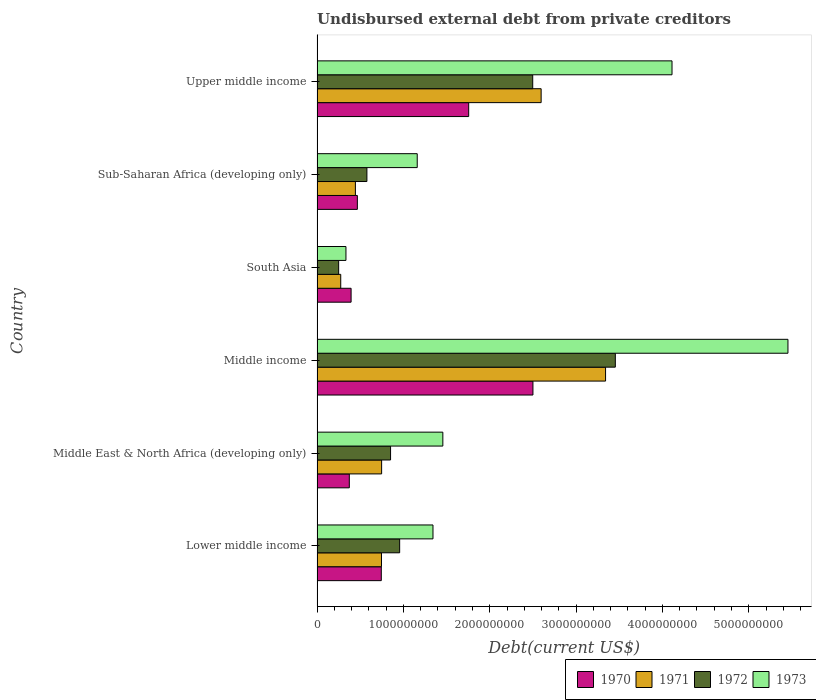How many groups of bars are there?
Provide a succinct answer. 6. Are the number of bars on each tick of the Y-axis equal?
Your answer should be compact. Yes. How many bars are there on the 2nd tick from the top?
Give a very brief answer. 4. What is the label of the 5th group of bars from the top?
Keep it short and to the point. Middle East & North Africa (developing only). In how many cases, is the number of bars for a given country not equal to the number of legend labels?
Offer a very short reply. 0. What is the total debt in 1972 in Sub-Saharan Africa (developing only)?
Make the answer very short. 5.77e+08. Across all countries, what is the maximum total debt in 1972?
Your answer should be compact. 3.45e+09. Across all countries, what is the minimum total debt in 1972?
Give a very brief answer. 2.50e+08. What is the total total debt in 1970 in the graph?
Your response must be concise. 6.24e+09. What is the difference between the total debt in 1972 in Lower middle income and that in Upper middle income?
Your response must be concise. -1.54e+09. What is the difference between the total debt in 1972 in Middle income and the total debt in 1973 in Upper middle income?
Your answer should be compact. -6.57e+08. What is the average total debt in 1971 per country?
Give a very brief answer. 1.36e+09. What is the difference between the total debt in 1971 and total debt in 1970 in Middle East & North Africa (developing only)?
Provide a short and direct response. 3.74e+08. What is the ratio of the total debt in 1971 in South Asia to that in Sub-Saharan Africa (developing only)?
Give a very brief answer. 0.62. Is the total debt in 1971 in Middle East & North Africa (developing only) less than that in Upper middle income?
Make the answer very short. Yes. Is the difference between the total debt in 1971 in Middle East & North Africa (developing only) and Sub-Saharan Africa (developing only) greater than the difference between the total debt in 1970 in Middle East & North Africa (developing only) and Sub-Saharan Africa (developing only)?
Your answer should be compact. Yes. What is the difference between the highest and the second highest total debt in 1971?
Offer a terse response. 7.46e+08. What is the difference between the highest and the lowest total debt in 1970?
Offer a terse response. 2.13e+09. In how many countries, is the total debt in 1971 greater than the average total debt in 1971 taken over all countries?
Keep it short and to the point. 2. Is the sum of the total debt in 1972 in Lower middle income and Middle income greater than the maximum total debt in 1971 across all countries?
Provide a succinct answer. Yes. Is it the case that in every country, the sum of the total debt in 1972 and total debt in 1970 is greater than the sum of total debt in 1971 and total debt in 1973?
Your answer should be compact. No. What does the 3rd bar from the top in Middle East & North Africa (developing only) represents?
Your response must be concise. 1971. Is it the case that in every country, the sum of the total debt in 1970 and total debt in 1972 is greater than the total debt in 1971?
Your answer should be compact. Yes. How many bars are there?
Your answer should be compact. 24. How many countries are there in the graph?
Provide a succinct answer. 6. What is the difference between two consecutive major ticks on the X-axis?
Ensure brevity in your answer.  1.00e+09. Does the graph contain any zero values?
Offer a very short reply. No. Does the graph contain grids?
Provide a succinct answer. No. Where does the legend appear in the graph?
Your answer should be compact. Bottom right. How are the legend labels stacked?
Your response must be concise. Horizontal. What is the title of the graph?
Your answer should be very brief. Undisbursed external debt from private creditors. Does "1998" appear as one of the legend labels in the graph?
Keep it short and to the point. No. What is the label or title of the X-axis?
Provide a succinct answer. Debt(current US$). What is the Debt(current US$) of 1970 in Lower middle income?
Provide a succinct answer. 7.44e+08. What is the Debt(current US$) of 1971 in Lower middle income?
Your response must be concise. 7.46e+08. What is the Debt(current US$) in 1972 in Lower middle income?
Offer a terse response. 9.57e+08. What is the Debt(current US$) of 1973 in Lower middle income?
Offer a very short reply. 1.34e+09. What is the Debt(current US$) of 1970 in Middle East & North Africa (developing only)?
Your answer should be very brief. 3.74e+08. What is the Debt(current US$) of 1971 in Middle East & North Africa (developing only)?
Offer a terse response. 7.48e+08. What is the Debt(current US$) in 1972 in Middle East & North Africa (developing only)?
Provide a short and direct response. 8.51e+08. What is the Debt(current US$) of 1973 in Middle East & North Africa (developing only)?
Provide a short and direct response. 1.46e+09. What is the Debt(current US$) of 1970 in Middle income?
Offer a terse response. 2.50e+09. What is the Debt(current US$) in 1971 in Middle income?
Provide a short and direct response. 3.34e+09. What is the Debt(current US$) of 1972 in Middle income?
Give a very brief answer. 3.45e+09. What is the Debt(current US$) in 1973 in Middle income?
Make the answer very short. 5.45e+09. What is the Debt(current US$) in 1970 in South Asia?
Your answer should be compact. 3.94e+08. What is the Debt(current US$) in 1971 in South Asia?
Make the answer very short. 2.74e+08. What is the Debt(current US$) of 1972 in South Asia?
Provide a succinct answer. 2.50e+08. What is the Debt(current US$) of 1973 in South Asia?
Provide a short and direct response. 3.35e+08. What is the Debt(current US$) of 1970 in Sub-Saharan Africa (developing only)?
Your answer should be compact. 4.67e+08. What is the Debt(current US$) in 1971 in Sub-Saharan Africa (developing only)?
Give a very brief answer. 4.44e+08. What is the Debt(current US$) in 1972 in Sub-Saharan Africa (developing only)?
Keep it short and to the point. 5.77e+08. What is the Debt(current US$) of 1973 in Sub-Saharan Africa (developing only)?
Your answer should be compact. 1.16e+09. What is the Debt(current US$) in 1970 in Upper middle income?
Provide a short and direct response. 1.76e+09. What is the Debt(current US$) in 1971 in Upper middle income?
Your answer should be very brief. 2.60e+09. What is the Debt(current US$) of 1972 in Upper middle income?
Your response must be concise. 2.50e+09. What is the Debt(current US$) of 1973 in Upper middle income?
Offer a very short reply. 4.11e+09. Across all countries, what is the maximum Debt(current US$) in 1970?
Offer a terse response. 2.50e+09. Across all countries, what is the maximum Debt(current US$) of 1971?
Your response must be concise. 3.34e+09. Across all countries, what is the maximum Debt(current US$) in 1972?
Offer a terse response. 3.45e+09. Across all countries, what is the maximum Debt(current US$) in 1973?
Provide a short and direct response. 5.45e+09. Across all countries, what is the minimum Debt(current US$) of 1970?
Keep it short and to the point. 3.74e+08. Across all countries, what is the minimum Debt(current US$) in 1971?
Offer a terse response. 2.74e+08. Across all countries, what is the minimum Debt(current US$) in 1972?
Provide a short and direct response. 2.50e+08. Across all countries, what is the minimum Debt(current US$) in 1973?
Give a very brief answer. 3.35e+08. What is the total Debt(current US$) in 1970 in the graph?
Offer a terse response. 6.24e+09. What is the total Debt(current US$) of 1971 in the graph?
Your answer should be very brief. 8.15e+09. What is the total Debt(current US$) of 1972 in the graph?
Offer a terse response. 8.59e+09. What is the total Debt(current US$) of 1973 in the graph?
Give a very brief answer. 1.39e+1. What is the difference between the Debt(current US$) of 1970 in Lower middle income and that in Middle East & North Africa (developing only)?
Make the answer very short. 3.71e+08. What is the difference between the Debt(current US$) of 1971 in Lower middle income and that in Middle East & North Africa (developing only)?
Your answer should be very brief. -1.62e+06. What is the difference between the Debt(current US$) of 1972 in Lower middle income and that in Middle East & North Africa (developing only)?
Your answer should be compact. 1.05e+08. What is the difference between the Debt(current US$) of 1973 in Lower middle income and that in Middle East & North Africa (developing only)?
Provide a succinct answer. -1.14e+08. What is the difference between the Debt(current US$) of 1970 in Lower middle income and that in Middle income?
Ensure brevity in your answer.  -1.76e+09. What is the difference between the Debt(current US$) in 1971 in Lower middle income and that in Middle income?
Offer a terse response. -2.60e+09. What is the difference between the Debt(current US$) in 1972 in Lower middle income and that in Middle income?
Ensure brevity in your answer.  -2.50e+09. What is the difference between the Debt(current US$) of 1973 in Lower middle income and that in Middle income?
Your answer should be very brief. -4.11e+09. What is the difference between the Debt(current US$) of 1970 in Lower middle income and that in South Asia?
Keep it short and to the point. 3.50e+08. What is the difference between the Debt(current US$) in 1971 in Lower middle income and that in South Asia?
Offer a terse response. 4.72e+08. What is the difference between the Debt(current US$) of 1972 in Lower middle income and that in South Asia?
Give a very brief answer. 7.07e+08. What is the difference between the Debt(current US$) of 1973 in Lower middle income and that in South Asia?
Keep it short and to the point. 1.01e+09. What is the difference between the Debt(current US$) in 1970 in Lower middle income and that in Sub-Saharan Africa (developing only)?
Your answer should be very brief. 2.77e+08. What is the difference between the Debt(current US$) in 1971 in Lower middle income and that in Sub-Saharan Africa (developing only)?
Keep it short and to the point. 3.02e+08. What is the difference between the Debt(current US$) in 1972 in Lower middle income and that in Sub-Saharan Africa (developing only)?
Offer a very short reply. 3.79e+08. What is the difference between the Debt(current US$) of 1973 in Lower middle income and that in Sub-Saharan Africa (developing only)?
Provide a short and direct response. 1.82e+08. What is the difference between the Debt(current US$) in 1970 in Lower middle income and that in Upper middle income?
Give a very brief answer. -1.01e+09. What is the difference between the Debt(current US$) in 1971 in Lower middle income and that in Upper middle income?
Your response must be concise. -1.85e+09. What is the difference between the Debt(current US$) in 1972 in Lower middle income and that in Upper middle income?
Make the answer very short. -1.54e+09. What is the difference between the Debt(current US$) of 1973 in Lower middle income and that in Upper middle income?
Your response must be concise. -2.77e+09. What is the difference between the Debt(current US$) in 1970 in Middle East & North Africa (developing only) and that in Middle income?
Keep it short and to the point. -2.13e+09. What is the difference between the Debt(current US$) in 1971 in Middle East & North Africa (developing only) and that in Middle income?
Offer a very short reply. -2.59e+09. What is the difference between the Debt(current US$) in 1972 in Middle East & North Africa (developing only) and that in Middle income?
Make the answer very short. -2.60e+09. What is the difference between the Debt(current US$) in 1973 in Middle East & North Africa (developing only) and that in Middle income?
Your answer should be compact. -4.00e+09. What is the difference between the Debt(current US$) of 1970 in Middle East & North Africa (developing only) and that in South Asia?
Provide a short and direct response. -2.07e+07. What is the difference between the Debt(current US$) of 1971 in Middle East & North Africa (developing only) and that in South Asia?
Provide a short and direct response. 4.74e+08. What is the difference between the Debt(current US$) of 1972 in Middle East & North Africa (developing only) and that in South Asia?
Keep it short and to the point. 6.01e+08. What is the difference between the Debt(current US$) in 1973 in Middle East & North Africa (developing only) and that in South Asia?
Provide a succinct answer. 1.12e+09. What is the difference between the Debt(current US$) of 1970 in Middle East & North Africa (developing only) and that in Sub-Saharan Africa (developing only)?
Provide a succinct answer. -9.32e+07. What is the difference between the Debt(current US$) of 1971 in Middle East & North Africa (developing only) and that in Sub-Saharan Africa (developing only)?
Give a very brief answer. 3.04e+08. What is the difference between the Debt(current US$) in 1972 in Middle East & North Africa (developing only) and that in Sub-Saharan Africa (developing only)?
Provide a short and direct response. 2.74e+08. What is the difference between the Debt(current US$) of 1973 in Middle East & North Africa (developing only) and that in Sub-Saharan Africa (developing only)?
Provide a short and direct response. 2.97e+08. What is the difference between the Debt(current US$) in 1970 in Middle East & North Africa (developing only) and that in Upper middle income?
Give a very brief answer. -1.38e+09. What is the difference between the Debt(current US$) of 1971 in Middle East & North Africa (developing only) and that in Upper middle income?
Your answer should be very brief. -1.85e+09. What is the difference between the Debt(current US$) in 1972 in Middle East & North Africa (developing only) and that in Upper middle income?
Your answer should be compact. -1.65e+09. What is the difference between the Debt(current US$) of 1973 in Middle East & North Africa (developing only) and that in Upper middle income?
Keep it short and to the point. -2.65e+09. What is the difference between the Debt(current US$) in 1970 in Middle income and that in South Asia?
Offer a very short reply. 2.11e+09. What is the difference between the Debt(current US$) of 1971 in Middle income and that in South Asia?
Keep it short and to the point. 3.07e+09. What is the difference between the Debt(current US$) of 1972 in Middle income and that in South Asia?
Ensure brevity in your answer.  3.20e+09. What is the difference between the Debt(current US$) of 1973 in Middle income and that in South Asia?
Offer a very short reply. 5.12e+09. What is the difference between the Debt(current US$) of 1970 in Middle income and that in Sub-Saharan Africa (developing only)?
Your response must be concise. 2.03e+09. What is the difference between the Debt(current US$) of 1971 in Middle income and that in Sub-Saharan Africa (developing only)?
Ensure brevity in your answer.  2.90e+09. What is the difference between the Debt(current US$) in 1972 in Middle income and that in Sub-Saharan Africa (developing only)?
Ensure brevity in your answer.  2.88e+09. What is the difference between the Debt(current US$) of 1973 in Middle income and that in Sub-Saharan Africa (developing only)?
Your response must be concise. 4.29e+09. What is the difference between the Debt(current US$) of 1970 in Middle income and that in Upper middle income?
Your answer should be very brief. 7.44e+08. What is the difference between the Debt(current US$) of 1971 in Middle income and that in Upper middle income?
Provide a short and direct response. 7.46e+08. What is the difference between the Debt(current US$) in 1972 in Middle income and that in Upper middle income?
Offer a very short reply. 9.57e+08. What is the difference between the Debt(current US$) in 1973 in Middle income and that in Upper middle income?
Offer a very short reply. 1.34e+09. What is the difference between the Debt(current US$) of 1970 in South Asia and that in Sub-Saharan Africa (developing only)?
Your answer should be compact. -7.26e+07. What is the difference between the Debt(current US$) in 1971 in South Asia and that in Sub-Saharan Africa (developing only)?
Offer a terse response. -1.70e+08. What is the difference between the Debt(current US$) in 1972 in South Asia and that in Sub-Saharan Africa (developing only)?
Ensure brevity in your answer.  -3.27e+08. What is the difference between the Debt(current US$) of 1973 in South Asia and that in Sub-Saharan Africa (developing only)?
Provide a succinct answer. -8.26e+08. What is the difference between the Debt(current US$) of 1970 in South Asia and that in Upper middle income?
Provide a short and direct response. -1.36e+09. What is the difference between the Debt(current US$) in 1971 in South Asia and that in Upper middle income?
Provide a succinct answer. -2.32e+09. What is the difference between the Debt(current US$) of 1972 in South Asia and that in Upper middle income?
Offer a terse response. -2.25e+09. What is the difference between the Debt(current US$) of 1973 in South Asia and that in Upper middle income?
Make the answer very short. -3.78e+09. What is the difference between the Debt(current US$) of 1970 in Sub-Saharan Africa (developing only) and that in Upper middle income?
Ensure brevity in your answer.  -1.29e+09. What is the difference between the Debt(current US$) in 1971 in Sub-Saharan Africa (developing only) and that in Upper middle income?
Ensure brevity in your answer.  -2.15e+09. What is the difference between the Debt(current US$) of 1972 in Sub-Saharan Africa (developing only) and that in Upper middle income?
Provide a succinct answer. -1.92e+09. What is the difference between the Debt(current US$) of 1973 in Sub-Saharan Africa (developing only) and that in Upper middle income?
Make the answer very short. -2.95e+09. What is the difference between the Debt(current US$) of 1970 in Lower middle income and the Debt(current US$) of 1971 in Middle East & North Africa (developing only)?
Your answer should be compact. -3.71e+06. What is the difference between the Debt(current US$) in 1970 in Lower middle income and the Debt(current US$) in 1972 in Middle East & North Africa (developing only)?
Make the answer very short. -1.07e+08. What is the difference between the Debt(current US$) of 1970 in Lower middle income and the Debt(current US$) of 1973 in Middle East & North Africa (developing only)?
Keep it short and to the point. -7.13e+08. What is the difference between the Debt(current US$) of 1971 in Lower middle income and the Debt(current US$) of 1972 in Middle East & North Africa (developing only)?
Your response must be concise. -1.05e+08. What is the difference between the Debt(current US$) in 1971 in Lower middle income and the Debt(current US$) in 1973 in Middle East & North Africa (developing only)?
Your answer should be very brief. -7.11e+08. What is the difference between the Debt(current US$) in 1972 in Lower middle income and the Debt(current US$) in 1973 in Middle East & North Africa (developing only)?
Your answer should be compact. -5.00e+08. What is the difference between the Debt(current US$) in 1970 in Lower middle income and the Debt(current US$) in 1971 in Middle income?
Your response must be concise. -2.60e+09. What is the difference between the Debt(current US$) of 1970 in Lower middle income and the Debt(current US$) of 1972 in Middle income?
Your answer should be compact. -2.71e+09. What is the difference between the Debt(current US$) in 1970 in Lower middle income and the Debt(current US$) in 1973 in Middle income?
Your response must be concise. -4.71e+09. What is the difference between the Debt(current US$) of 1971 in Lower middle income and the Debt(current US$) of 1972 in Middle income?
Offer a very short reply. -2.71e+09. What is the difference between the Debt(current US$) in 1971 in Lower middle income and the Debt(current US$) in 1973 in Middle income?
Make the answer very short. -4.71e+09. What is the difference between the Debt(current US$) of 1972 in Lower middle income and the Debt(current US$) of 1973 in Middle income?
Provide a short and direct response. -4.50e+09. What is the difference between the Debt(current US$) in 1970 in Lower middle income and the Debt(current US$) in 1971 in South Asia?
Keep it short and to the point. 4.70e+08. What is the difference between the Debt(current US$) of 1970 in Lower middle income and the Debt(current US$) of 1972 in South Asia?
Your answer should be compact. 4.94e+08. What is the difference between the Debt(current US$) in 1970 in Lower middle income and the Debt(current US$) in 1973 in South Asia?
Offer a very short reply. 4.09e+08. What is the difference between the Debt(current US$) of 1971 in Lower middle income and the Debt(current US$) of 1972 in South Asia?
Provide a succinct answer. 4.96e+08. What is the difference between the Debt(current US$) in 1971 in Lower middle income and the Debt(current US$) in 1973 in South Asia?
Make the answer very short. 4.11e+08. What is the difference between the Debt(current US$) of 1972 in Lower middle income and the Debt(current US$) of 1973 in South Asia?
Make the answer very short. 6.22e+08. What is the difference between the Debt(current US$) of 1970 in Lower middle income and the Debt(current US$) of 1971 in Sub-Saharan Africa (developing only)?
Keep it short and to the point. 3.00e+08. What is the difference between the Debt(current US$) of 1970 in Lower middle income and the Debt(current US$) of 1972 in Sub-Saharan Africa (developing only)?
Provide a short and direct response. 1.67e+08. What is the difference between the Debt(current US$) of 1970 in Lower middle income and the Debt(current US$) of 1973 in Sub-Saharan Africa (developing only)?
Provide a succinct answer. -4.16e+08. What is the difference between the Debt(current US$) of 1971 in Lower middle income and the Debt(current US$) of 1972 in Sub-Saharan Africa (developing only)?
Provide a succinct answer. 1.69e+08. What is the difference between the Debt(current US$) of 1971 in Lower middle income and the Debt(current US$) of 1973 in Sub-Saharan Africa (developing only)?
Offer a very short reply. -4.14e+08. What is the difference between the Debt(current US$) in 1972 in Lower middle income and the Debt(current US$) in 1973 in Sub-Saharan Africa (developing only)?
Provide a short and direct response. -2.04e+08. What is the difference between the Debt(current US$) in 1970 in Lower middle income and the Debt(current US$) in 1971 in Upper middle income?
Your answer should be very brief. -1.85e+09. What is the difference between the Debt(current US$) of 1970 in Lower middle income and the Debt(current US$) of 1972 in Upper middle income?
Provide a succinct answer. -1.75e+09. What is the difference between the Debt(current US$) of 1970 in Lower middle income and the Debt(current US$) of 1973 in Upper middle income?
Your answer should be very brief. -3.37e+09. What is the difference between the Debt(current US$) in 1971 in Lower middle income and the Debt(current US$) in 1972 in Upper middle income?
Your answer should be very brief. -1.75e+09. What is the difference between the Debt(current US$) in 1971 in Lower middle income and the Debt(current US$) in 1973 in Upper middle income?
Offer a terse response. -3.37e+09. What is the difference between the Debt(current US$) in 1972 in Lower middle income and the Debt(current US$) in 1973 in Upper middle income?
Keep it short and to the point. -3.15e+09. What is the difference between the Debt(current US$) in 1970 in Middle East & North Africa (developing only) and the Debt(current US$) in 1971 in Middle income?
Provide a short and direct response. -2.97e+09. What is the difference between the Debt(current US$) of 1970 in Middle East & North Africa (developing only) and the Debt(current US$) of 1972 in Middle income?
Your answer should be compact. -3.08e+09. What is the difference between the Debt(current US$) of 1970 in Middle East & North Africa (developing only) and the Debt(current US$) of 1973 in Middle income?
Offer a terse response. -5.08e+09. What is the difference between the Debt(current US$) of 1971 in Middle East & North Africa (developing only) and the Debt(current US$) of 1972 in Middle income?
Provide a short and direct response. -2.71e+09. What is the difference between the Debt(current US$) in 1971 in Middle East & North Africa (developing only) and the Debt(current US$) in 1973 in Middle income?
Your answer should be very brief. -4.71e+09. What is the difference between the Debt(current US$) of 1972 in Middle East & North Africa (developing only) and the Debt(current US$) of 1973 in Middle income?
Your response must be concise. -4.60e+09. What is the difference between the Debt(current US$) in 1970 in Middle East & North Africa (developing only) and the Debt(current US$) in 1971 in South Asia?
Make the answer very short. 9.92e+07. What is the difference between the Debt(current US$) of 1970 in Middle East & North Africa (developing only) and the Debt(current US$) of 1972 in South Asia?
Your response must be concise. 1.23e+08. What is the difference between the Debt(current US$) in 1970 in Middle East & North Africa (developing only) and the Debt(current US$) in 1973 in South Asia?
Your answer should be compact. 3.88e+07. What is the difference between the Debt(current US$) in 1971 in Middle East & North Africa (developing only) and the Debt(current US$) in 1972 in South Asia?
Give a very brief answer. 4.98e+08. What is the difference between the Debt(current US$) in 1971 in Middle East & North Africa (developing only) and the Debt(current US$) in 1973 in South Asia?
Offer a terse response. 4.13e+08. What is the difference between the Debt(current US$) in 1972 in Middle East & North Africa (developing only) and the Debt(current US$) in 1973 in South Asia?
Keep it short and to the point. 5.17e+08. What is the difference between the Debt(current US$) in 1970 in Middle East & North Africa (developing only) and the Debt(current US$) in 1971 in Sub-Saharan Africa (developing only)?
Your answer should be very brief. -7.04e+07. What is the difference between the Debt(current US$) of 1970 in Middle East & North Africa (developing only) and the Debt(current US$) of 1972 in Sub-Saharan Africa (developing only)?
Ensure brevity in your answer.  -2.04e+08. What is the difference between the Debt(current US$) of 1970 in Middle East & North Africa (developing only) and the Debt(current US$) of 1973 in Sub-Saharan Africa (developing only)?
Offer a very short reply. -7.87e+08. What is the difference between the Debt(current US$) in 1971 in Middle East & North Africa (developing only) and the Debt(current US$) in 1972 in Sub-Saharan Africa (developing only)?
Provide a short and direct response. 1.70e+08. What is the difference between the Debt(current US$) in 1971 in Middle East & North Africa (developing only) and the Debt(current US$) in 1973 in Sub-Saharan Africa (developing only)?
Make the answer very short. -4.12e+08. What is the difference between the Debt(current US$) in 1972 in Middle East & North Africa (developing only) and the Debt(current US$) in 1973 in Sub-Saharan Africa (developing only)?
Offer a terse response. -3.09e+08. What is the difference between the Debt(current US$) in 1970 in Middle East & North Africa (developing only) and the Debt(current US$) in 1971 in Upper middle income?
Give a very brief answer. -2.22e+09. What is the difference between the Debt(current US$) of 1970 in Middle East & North Africa (developing only) and the Debt(current US$) of 1972 in Upper middle income?
Your answer should be compact. -2.12e+09. What is the difference between the Debt(current US$) in 1970 in Middle East & North Africa (developing only) and the Debt(current US$) in 1973 in Upper middle income?
Keep it short and to the point. -3.74e+09. What is the difference between the Debt(current US$) in 1971 in Middle East & North Africa (developing only) and the Debt(current US$) in 1972 in Upper middle income?
Your answer should be compact. -1.75e+09. What is the difference between the Debt(current US$) in 1971 in Middle East & North Africa (developing only) and the Debt(current US$) in 1973 in Upper middle income?
Ensure brevity in your answer.  -3.36e+09. What is the difference between the Debt(current US$) in 1972 in Middle East & North Africa (developing only) and the Debt(current US$) in 1973 in Upper middle income?
Make the answer very short. -3.26e+09. What is the difference between the Debt(current US$) of 1970 in Middle income and the Debt(current US$) of 1971 in South Asia?
Give a very brief answer. 2.23e+09. What is the difference between the Debt(current US$) of 1970 in Middle income and the Debt(current US$) of 1972 in South Asia?
Give a very brief answer. 2.25e+09. What is the difference between the Debt(current US$) in 1970 in Middle income and the Debt(current US$) in 1973 in South Asia?
Give a very brief answer. 2.17e+09. What is the difference between the Debt(current US$) in 1971 in Middle income and the Debt(current US$) in 1972 in South Asia?
Your response must be concise. 3.09e+09. What is the difference between the Debt(current US$) in 1971 in Middle income and the Debt(current US$) in 1973 in South Asia?
Offer a very short reply. 3.01e+09. What is the difference between the Debt(current US$) in 1972 in Middle income and the Debt(current US$) in 1973 in South Asia?
Your answer should be compact. 3.12e+09. What is the difference between the Debt(current US$) in 1970 in Middle income and the Debt(current US$) in 1971 in Sub-Saharan Africa (developing only)?
Your answer should be very brief. 2.06e+09. What is the difference between the Debt(current US$) of 1970 in Middle income and the Debt(current US$) of 1972 in Sub-Saharan Africa (developing only)?
Offer a terse response. 1.92e+09. What is the difference between the Debt(current US$) in 1970 in Middle income and the Debt(current US$) in 1973 in Sub-Saharan Africa (developing only)?
Your answer should be very brief. 1.34e+09. What is the difference between the Debt(current US$) of 1971 in Middle income and the Debt(current US$) of 1972 in Sub-Saharan Africa (developing only)?
Give a very brief answer. 2.76e+09. What is the difference between the Debt(current US$) of 1971 in Middle income and the Debt(current US$) of 1973 in Sub-Saharan Africa (developing only)?
Ensure brevity in your answer.  2.18e+09. What is the difference between the Debt(current US$) in 1972 in Middle income and the Debt(current US$) in 1973 in Sub-Saharan Africa (developing only)?
Your response must be concise. 2.29e+09. What is the difference between the Debt(current US$) of 1970 in Middle income and the Debt(current US$) of 1971 in Upper middle income?
Your response must be concise. -9.50e+07. What is the difference between the Debt(current US$) in 1970 in Middle income and the Debt(current US$) in 1972 in Upper middle income?
Provide a succinct answer. 2.49e+06. What is the difference between the Debt(current US$) of 1970 in Middle income and the Debt(current US$) of 1973 in Upper middle income?
Provide a short and direct response. -1.61e+09. What is the difference between the Debt(current US$) in 1971 in Middle income and the Debt(current US$) in 1972 in Upper middle income?
Provide a short and direct response. 8.44e+08. What is the difference between the Debt(current US$) in 1971 in Middle income and the Debt(current US$) in 1973 in Upper middle income?
Make the answer very short. -7.70e+08. What is the difference between the Debt(current US$) of 1972 in Middle income and the Debt(current US$) of 1973 in Upper middle income?
Your response must be concise. -6.57e+08. What is the difference between the Debt(current US$) in 1970 in South Asia and the Debt(current US$) in 1971 in Sub-Saharan Africa (developing only)?
Your response must be concise. -4.98e+07. What is the difference between the Debt(current US$) of 1970 in South Asia and the Debt(current US$) of 1972 in Sub-Saharan Africa (developing only)?
Keep it short and to the point. -1.83e+08. What is the difference between the Debt(current US$) in 1970 in South Asia and the Debt(current US$) in 1973 in Sub-Saharan Africa (developing only)?
Ensure brevity in your answer.  -7.66e+08. What is the difference between the Debt(current US$) in 1971 in South Asia and the Debt(current US$) in 1972 in Sub-Saharan Africa (developing only)?
Provide a short and direct response. -3.03e+08. What is the difference between the Debt(current US$) in 1971 in South Asia and the Debt(current US$) in 1973 in Sub-Saharan Africa (developing only)?
Your answer should be very brief. -8.86e+08. What is the difference between the Debt(current US$) in 1972 in South Asia and the Debt(current US$) in 1973 in Sub-Saharan Africa (developing only)?
Your answer should be very brief. -9.10e+08. What is the difference between the Debt(current US$) of 1970 in South Asia and the Debt(current US$) of 1971 in Upper middle income?
Keep it short and to the point. -2.20e+09. What is the difference between the Debt(current US$) of 1970 in South Asia and the Debt(current US$) of 1972 in Upper middle income?
Your answer should be compact. -2.10e+09. What is the difference between the Debt(current US$) in 1970 in South Asia and the Debt(current US$) in 1973 in Upper middle income?
Provide a succinct answer. -3.72e+09. What is the difference between the Debt(current US$) of 1971 in South Asia and the Debt(current US$) of 1972 in Upper middle income?
Your answer should be compact. -2.22e+09. What is the difference between the Debt(current US$) in 1971 in South Asia and the Debt(current US$) in 1973 in Upper middle income?
Your response must be concise. -3.84e+09. What is the difference between the Debt(current US$) in 1972 in South Asia and the Debt(current US$) in 1973 in Upper middle income?
Provide a short and direct response. -3.86e+09. What is the difference between the Debt(current US$) in 1970 in Sub-Saharan Africa (developing only) and the Debt(current US$) in 1971 in Upper middle income?
Offer a terse response. -2.13e+09. What is the difference between the Debt(current US$) in 1970 in Sub-Saharan Africa (developing only) and the Debt(current US$) in 1972 in Upper middle income?
Ensure brevity in your answer.  -2.03e+09. What is the difference between the Debt(current US$) of 1970 in Sub-Saharan Africa (developing only) and the Debt(current US$) of 1973 in Upper middle income?
Your response must be concise. -3.64e+09. What is the difference between the Debt(current US$) of 1971 in Sub-Saharan Africa (developing only) and the Debt(current US$) of 1972 in Upper middle income?
Ensure brevity in your answer.  -2.05e+09. What is the difference between the Debt(current US$) of 1971 in Sub-Saharan Africa (developing only) and the Debt(current US$) of 1973 in Upper middle income?
Provide a short and direct response. -3.67e+09. What is the difference between the Debt(current US$) of 1972 in Sub-Saharan Africa (developing only) and the Debt(current US$) of 1973 in Upper middle income?
Your answer should be very brief. -3.53e+09. What is the average Debt(current US$) in 1970 per country?
Offer a very short reply. 1.04e+09. What is the average Debt(current US$) of 1971 per country?
Your answer should be compact. 1.36e+09. What is the average Debt(current US$) of 1972 per country?
Your response must be concise. 1.43e+09. What is the average Debt(current US$) in 1973 per country?
Offer a very short reply. 2.31e+09. What is the difference between the Debt(current US$) of 1970 and Debt(current US$) of 1971 in Lower middle income?
Provide a short and direct response. -2.10e+06. What is the difference between the Debt(current US$) in 1970 and Debt(current US$) in 1972 in Lower middle income?
Ensure brevity in your answer.  -2.13e+08. What is the difference between the Debt(current US$) of 1970 and Debt(current US$) of 1973 in Lower middle income?
Provide a succinct answer. -5.99e+08. What is the difference between the Debt(current US$) of 1971 and Debt(current US$) of 1972 in Lower middle income?
Your answer should be very brief. -2.11e+08. What is the difference between the Debt(current US$) of 1971 and Debt(current US$) of 1973 in Lower middle income?
Offer a terse response. -5.97e+08. What is the difference between the Debt(current US$) in 1972 and Debt(current US$) in 1973 in Lower middle income?
Your answer should be compact. -3.86e+08. What is the difference between the Debt(current US$) in 1970 and Debt(current US$) in 1971 in Middle East & North Africa (developing only)?
Ensure brevity in your answer.  -3.74e+08. What is the difference between the Debt(current US$) in 1970 and Debt(current US$) in 1972 in Middle East & North Africa (developing only)?
Offer a terse response. -4.78e+08. What is the difference between the Debt(current US$) of 1970 and Debt(current US$) of 1973 in Middle East & North Africa (developing only)?
Your answer should be very brief. -1.08e+09. What is the difference between the Debt(current US$) of 1971 and Debt(current US$) of 1972 in Middle East & North Africa (developing only)?
Make the answer very short. -1.04e+08. What is the difference between the Debt(current US$) of 1971 and Debt(current US$) of 1973 in Middle East & North Africa (developing only)?
Your answer should be compact. -7.09e+08. What is the difference between the Debt(current US$) of 1972 and Debt(current US$) of 1973 in Middle East & North Africa (developing only)?
Your answer should be very brief. -6.06e+08. What is the difference between the Debt(current US$) of 1970 and Debt(current US$) of 1971 in Middle income?
Your response must be concise. -8.41e+08. What is the difference between the Debt(current US$) of 1970 and Debt(current US$) of 1972 in Middle income?
Offer a very short reply. -9.54e+08. What is the difference between the Debt(current US$) of 1970 and Debt(current US$) of 1973 in Middle income?
Make the answer very short. -2.95e+09. What is the difference between the Debt(current US$) in 1971 and Debt(current US$) in 1972 in Middle income?
Offer a very short reply. -1.13e+08. What is the difference between the Debt(current US$) of 1971 and Debt(current US$) of 1973 in Middle income?
Make the answer very short. -2.11e+09. What is the difference between the Debt(current US$) in 1972 and Debt(current US$) in 1973 in Middle income?
Ensure brevity in your answer.  -2.00e+09. What is the difference between the Debt(current US$) of 1970 and Debt(current US$) of 1971 in South Asia?
Your answer should be very brief. 1.20e+08. What is the difference between the Debt(current US$) of 1970 and Debt(current US$) of 1972 in South Asia?
Keep it short and to the point. 1.44e+08. What is the difference between the Debt(current US$) in 1970 and Debt(current US$) in 1973 in South Asia?
Your answer should be compact. 5.95e+07. What is the difference between the Debt(current US$) of 1971 and Debt(current US$) of 1972 in South Asia?
Your answer should be compact. 2.41e+07. What is the difference between the Debt(current US$) of 1971 and Debt(current US$) of 1973 in South Asia?
Your answer should be very brief. -6.04e+07. What is the difference between the Debt(current US$) of 1972 and Debt(current US$) of 1973 in South Asia?
Keep it short and to the point. -8.45e+07. What is the difference between the Debt(current US$) in 1970 and Debt(current US$) in 1971 in Sub-Saharan Africa (developing only)?
Ensure brevity in your answer.  2.28e+07. What is the difference between the Debt(current US$) in 1970 and Debt(current US$) in 1972 in Sub-Saharan Africa (developing only)?
Offer a terse response. -1.11e+08. What is the difference between the Debt(current US$) of 1970 and Debt(current US$) of 1973 in Sub-Saharan Africa (developing only)?
Your answer should be compact. -6.94e+08. What is the difference between the Debt(current US$) of 1971 and Debt(current US$) of 1972 in Sub-Saharan Africa (developing only)?
Your answer should be compact. -1.33e+08. What is the difference between the Debt(current US$) in 1971 and Debt(current US$) in 1973 in Sub-Saharan Africa (developing only)?
Give a very brief answer. -7.16e+08. What is the difference between the Debt(current US$) of 1972 and Debt(current US$) of 1973 in Sub-Saharan Africa (developing only)?
Provide a short and direct response. -5.83e+08. What is the difference between the Debt(current US$) in 1970 and Debt(current US$) in 1971 in Upper middle income?
Your answer should be very brief. -8.39e+08. What is the difference between the Debt(current US$) of 1970 and Debt(current US$) of 1972 in Upper middle income?
Offer a terse response. -7.42e+08. What is the difference between the Debt(current US$) in 1970 and Debt(current US$) in 1973 in Upper middle income?
Your response must be concise. -2.36e+09. What is the difference between the Debt(current US$) of 1971 and Debt(current US$) of 1972 in Upper middle income?
Keep it short and to the point. 9.75e+07. What is the difference between the Debt(current US$) in 1971 and Debt(current US$) in 1973 in Upper middle income?
Your answer should be very brief. -1.52e+09. What is the difference between the Debt(current US$) of 1972 and Debt(current US$) of 1973 in Upper middle income?
Provide a succinct answer. -1.61e+09. What is the ratio of the Debt(current US$) of 1970 in Lower middle income to that in Middle East & North Africa (developing only)?
Your answer should be very brief. 1.99. What is the ratio of the Debt(current US$) in 1972 in Lower middle income to that in Middle East & North Africa (developing only)?
Your response must be concise. 1.12. What is the ratio of the Debt(current US$) of 1973 in Lower middle income to that in Middle East & North Africa (developing only)?
Your response must be concise. 0.92. What is the ratio of the Debt(current US$) of 1970 in Lower middle income to that in Middle income?
Ensure brevity in your answer.  0.3. What is the ratio of the Debt(current US$) of 1971 in Lower middle income to that in Middle income?
Make the answer very short. 0.22. What is the ratio of the Debt(current US$) in 1972 in Lower middle income to that in Middle income?
Give a very brief answer. 0.28. What is the ratio of the Debt(current US$) in 1973 in Lower middle income to that in Middle income?
Your answer should be compact. 0.25. What is the ratio of the Debt(current US$) in 1970 in Lower middle income to that in South Asia?
Provide a short and direct response. 1.89. What is the ratio of the Debt(current US$) in 1971 in Lower middle income to that in South Asia?
Your answer should be very brief. 2.72. What is the ratio of the Debt(current US$) in 1972 in Lower middle income to that in South Asia?
Keep it short and to the point. 3.82. What is the ratio of the Debt(current US$) of 1973 in Lower middle income to that in South Asia?
Your response must be concise. 4.01. What is the ratio of the Debt(current US$) in 1970 in Lower middle income to that in Sub-Saharan Africa (developing only)?
Provide a succinct answer. 1.59. What is the ratio of the Debt(current US$) in 1971 in Lower middle income to that in Sub-Saharan Africa (developing only)?
Your answer should be compact. 1.68. What is the ratio of the Debt(current US$) of 1972 in Lower middle income to that in Sub-Saharan Africa (developing only)?
Provide a short and direct response. 1.66. What is the ratio of the Debt(current US$) of 1973 in Lower middle income to that in Sub-Saharan Africa (developing only)?
Provide a succinct answer. 1.16. What is the ratio of the Debt(current US$) of 1970 in Lower middle income to that in Upper middle income?
Your answer should be compact. 0.42. What is the ratio of the Debt(current US$) in 1971 in Lower middle income to that in Upper middle income?
Provide a succinct answer. 0.29. What is the ratio of the Debt(current US$) of 1972 in Lower middle income to that in Upper middle income?
Provide a short and direct response. 0.38. What is the ratio of the Debt(current US$) in 1973 in Lower middle income to that in Upper middle income?
Keep it short and to the point. 0.33. What is the ratio of the Debt(current US$) of 1970 in Middle East & North Africa (developing only) to that in Middle income?
Your answer should be very brief. 0.15. What is the ratio of the Debt(current US$) in 1971 in Middle East & North Africa (developing only) to that in Middle income?
Your response must be concise. 0.22. What is the ratio of the Debt(current US$) of 1972 in Middle East & North Africa (developing only) to that in Middle income?
Provide a succinct answer. 0.25. What is the ratio of the Debt(current US$) of 1973 in Middle East & North Africa (developing only) to that in Middle income?
Provide a short and direct response. 0.27. What is the ratio of the Debt(current US$) of 1970 in Middle East & North Africa (developing only) to that in South Asia?
Offer a terse response. 0.95. What is the ratio of the Debt(current US$) of 1971 in Middle East & North Africa (developing only) to that in South Asia?
Keep it short and to the point. 2.73. What is the ratio of the Debt(current US$) of 1972 in Middle East & North Africa (developing only) to that in South Asia?
Provide a short and direct response. 3.4. What is the ratio of the Debt(current US$) in 1973 in Middle East & North Africa (developing only) to that in South Asia?
Provide a succinct answer. 4.35. What is the ratio of the Debt(current US$) in 1970 in Middle East & North Africa (developing only) to that in Sub-Saharan Africa (developing only)?
Keep it short and to the point. 0.8. What is the ratio of the Debt(current US$) of 1971 in Middle East & North Africa (developing only) to that in Sub-Saharan Africa (developing only)?
Keep it short and to the point. 1.68. What is the ratio of the Debt(current US$) of 1972 in Middle East & North Africa (developing only) to that in Sub-Saharan Africa (developing only)?
Provide a short and direct response. 1.47. What is the ratio of the Debt(current US$) in 1973 in Middle East & North Africa (developing only) to that in Sub-Saharan Africa (developing only)?
Provide a succinct answer. 1.26. What is the ratio of the Debt(current US$) of 1970 in Middle East & North Africa (developing only) to that in Upper middle income?
Your answer should be very brief. 0.21. What is the ratio of the Debt(current US$) in 1971 in Middle East & North Africa (developing only) to that in Upper middle income?
Ensure brevity in your answer.  0.29. What is the ratio of the Debt(current US$) in 1972 in Middle East & North Africa (developing only) to that in Upper middle income?
Offer a very short reply. 0.34. What is the ratio of the Debt(current US$) in 1973 in Middle East & North Africa (developing only) to that in Upper middle income?
Provide a succinct answer. 0.35. What is the ratio of the Debt(current US$) in 1970 in Middle income to that in South Asia?
Offer a terse response. 6.34. What is the ratio of the Debt(current US$) of 1971 in Middle income to that in South Asia?
Ensure brevity in your answer.  12.18. What is the ratio of the Debt(current US$) of 1972 in Middle income to that in South Asia?
Your answer should be very brief. 13.8. What is the ratio of the Debt(current US$) in 1973 in Middle income to that in South Asia?
Your answer should be very brief. 16.29. What is the ratio of the Debt(current US$) in 1970 in Middle income to that in Sub-Saharan Africa (developing only)?
Make the answer very short. 5.36. What is the ratio of the Debt(current US$) of 1971 in Middle income to that in Sub-Saharan Africa (developing only)?
Make the answer very short. 7.53. What is the ratio of the Debt(current US$) of 1972 in Middle income to that in Sub-Saharan Africa (developing only)?
Ensure brevity in your answer.  5.98. What is the ratio of the Debt(current US$) of 1973 in Middle income to that in Sub-Saharan Africa (developing only)?
Provide a succinct answer. 4.7. What is the ratio of the Debt(current US$) in 1970 in Middle income to that in Upper middle income?
Offer a very short reply. 1.42. What is the ratio of the Debt(current US$) in 1971 in Middle income to that in Upper middle income?
Give a very brief answer. 1.29. What is the ratio of the Debt(current US$) in 1972 in Middle income to that in Upper middle income?
Offer a terse response. 1.38. What is the ratio of the Debt(current US$) in 1973 in Middle income to that in Upper middle income?
Ensure brevity in your answer.  1.33. What is the ratio of the Debt(current US$) in 1970 in South Asia to that in Sub-Saharan Africa (developing only)?
Provide a short and direct response. 0.84. What is the ratio of the Debt(current US$) of 1971 in South Asia to that in Sub-Saharan Africa (developing only)?
Your answer should be compact. 0.62. What is the ratio of the Debt(current US$) of 1972 in South Asia to that in Sub-Saharan Africa (developing only)?
Your response must be concise. 0.43. What is the ratio of the Debt(current US$) of 1973 in South Asia to that in Sub-Saharan Africa (developing only)?
Give a very brief answer. 0.29. What is the ratio of the Debt(current US$) in 1970 in South Asia to that in Upper middle income?
Your answer should be compact. 0.22. What is the ratio of the Debt(current US$) of 1971 in South Asia to that in Upper middle income?
Provide a short and direct response. 0.11. What is the ratio of the Debt(current US$) of 1972 in South Asia to that in Upper middle income?
Offer a terse response. 0.1. What is the ratio of the Debt(current US$) in 1973 in South Asia to that in Upper middle income?
Give a very brief answer. 0.08. What is the ratio of the Debt(current US$) in 1970 in Sub-Saharan Africa (developing only) to that in Upper middle income?
Offer a terse response. 0.27. What is the ratio of the Debt(current US$) in 1971 in Sub-Saharan Africa (developing only) to that in Upper middle income?
Offer a very short reply. 0.17. What is the ratio of the Debt(current US$) in 1972 in Sub-Saharan Africa (developing only) to that in Upper middle income?
Give a very brief answer. 0.23. What is the ratio of the Debt(current US$) of 1973 in Sub-Saharan Africa (developing only) to that in Upper middle income?
Offer a very short reply. 0.28. What is the difference between the highest and the second highest Debt(current US$) in 1970?
Ensure brevity in your answer.  7.44e+08. What is the difference between the highest and the second highest Debt(current US$) in 1971?
Your answer should be very brief. 7.46e+08. What is the difference between the highest and the second highest Debt(current US$) in 1972?
Keep it short and to the point. 9.57e+08. What is the difference between the highest and the second highest Debt(current US$) of 1973?
Your response must be concise. 1.34e+09. What is the difference between the highest and the lowest Debt(current US$) of 1970?
Give a very brief answer. 2.13e+09. What is the difference between the highest and the lowest Debt(current US$) of 1971?
Keep it short and to the point. 3.07e+09. What is the difference between the highest and the lowest Debt(current US$) of 1972?
Ensure brevity in your answer.  3.20e+09. What is the difference between the highest and the lowest Debt(current US$) in 1973?
Provide a short and direct response. 5.12e+09. 